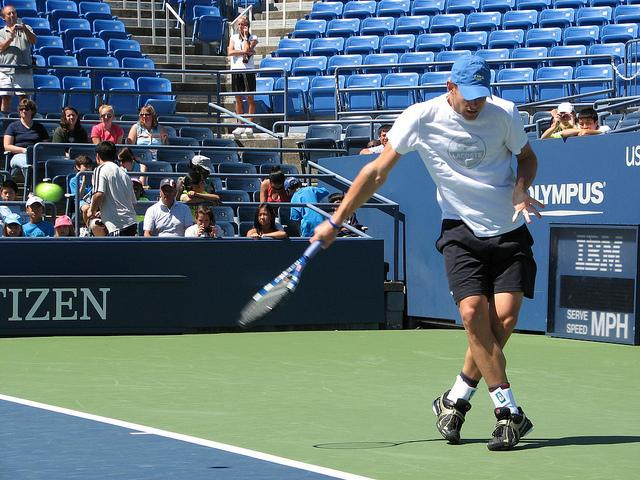What company is sponsoring the speed board?

Choices:
A) citizen
B) geico
C) ibm
D) olympus ibm 